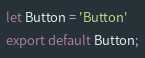Convert code to text. <code><loc_0><loc_0><loc_500><loc_500><_JavaScript_>
let Button = 'Button'
export default Button;</code> 